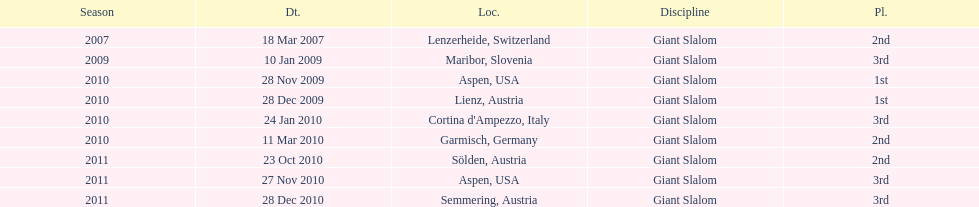The final race finishing place was not 1st but what other place? 3rd. 